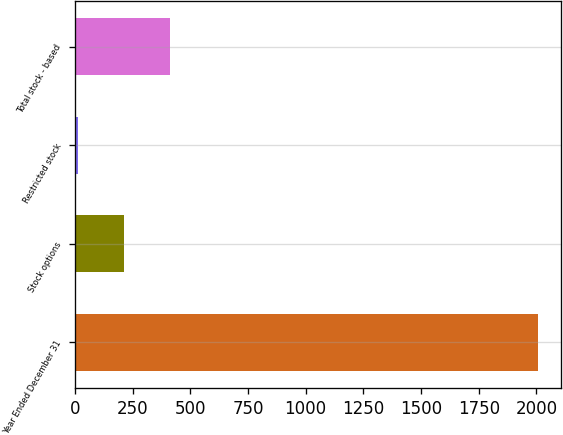Convert chart to OTSL. <chart><loc_0><loc_0><loc_500><loc_500><bar_chart><fcel>Year Ended December 31<fcel>Stock options<fcel>Restricted stock<fcel>Total stock - based<nl><fcel>2007<fcel>213.3<fcel>14<fcel>412.6<nl></chart> 